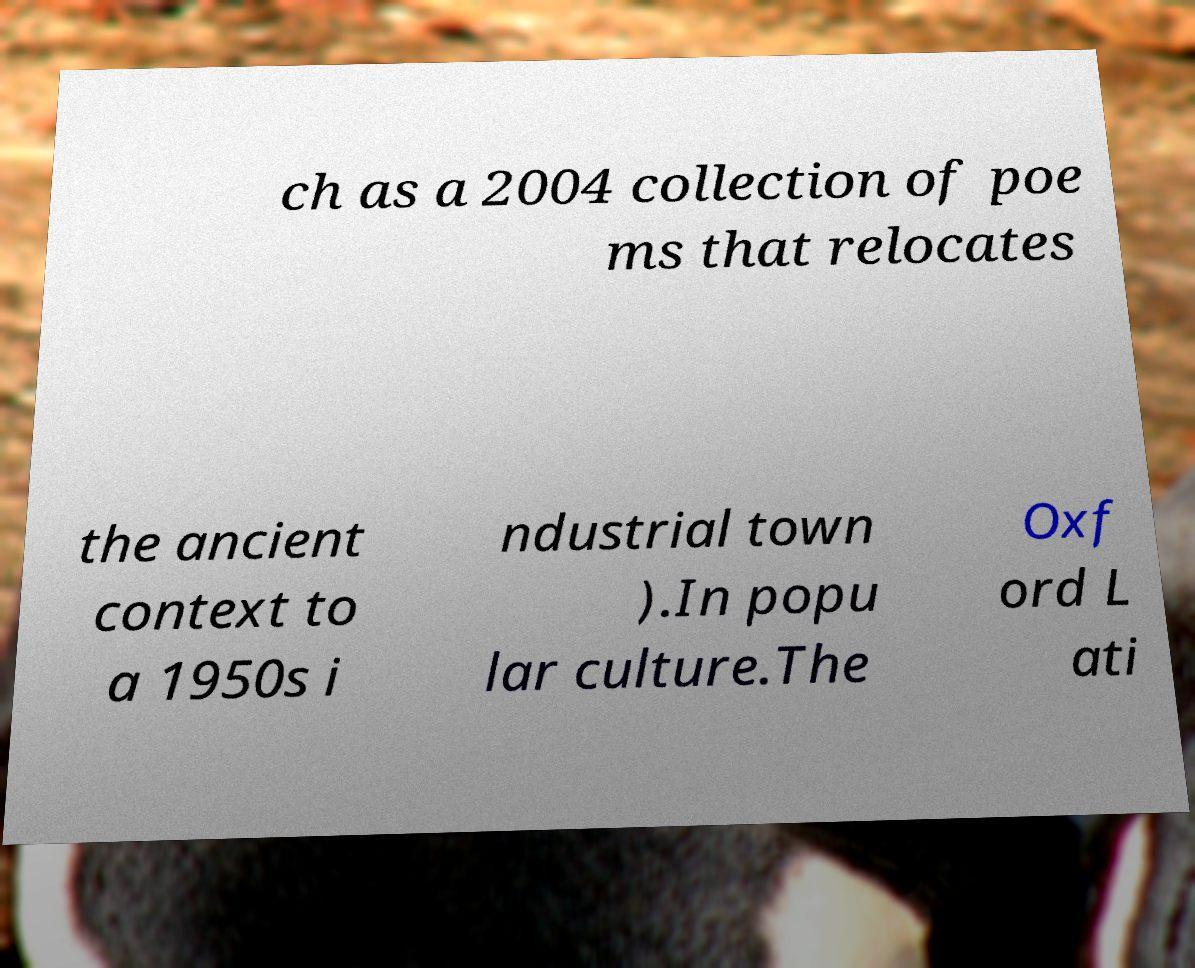Can you read and provide the text displayed in the image?This photo seems to have some interesting text. Can you extract and type it out for me? ch as a 2004 collection of poe ms that relocates the ancient context to a 1950s i ndustrial town ).In popu lar culture.The Oxf ord L ati 